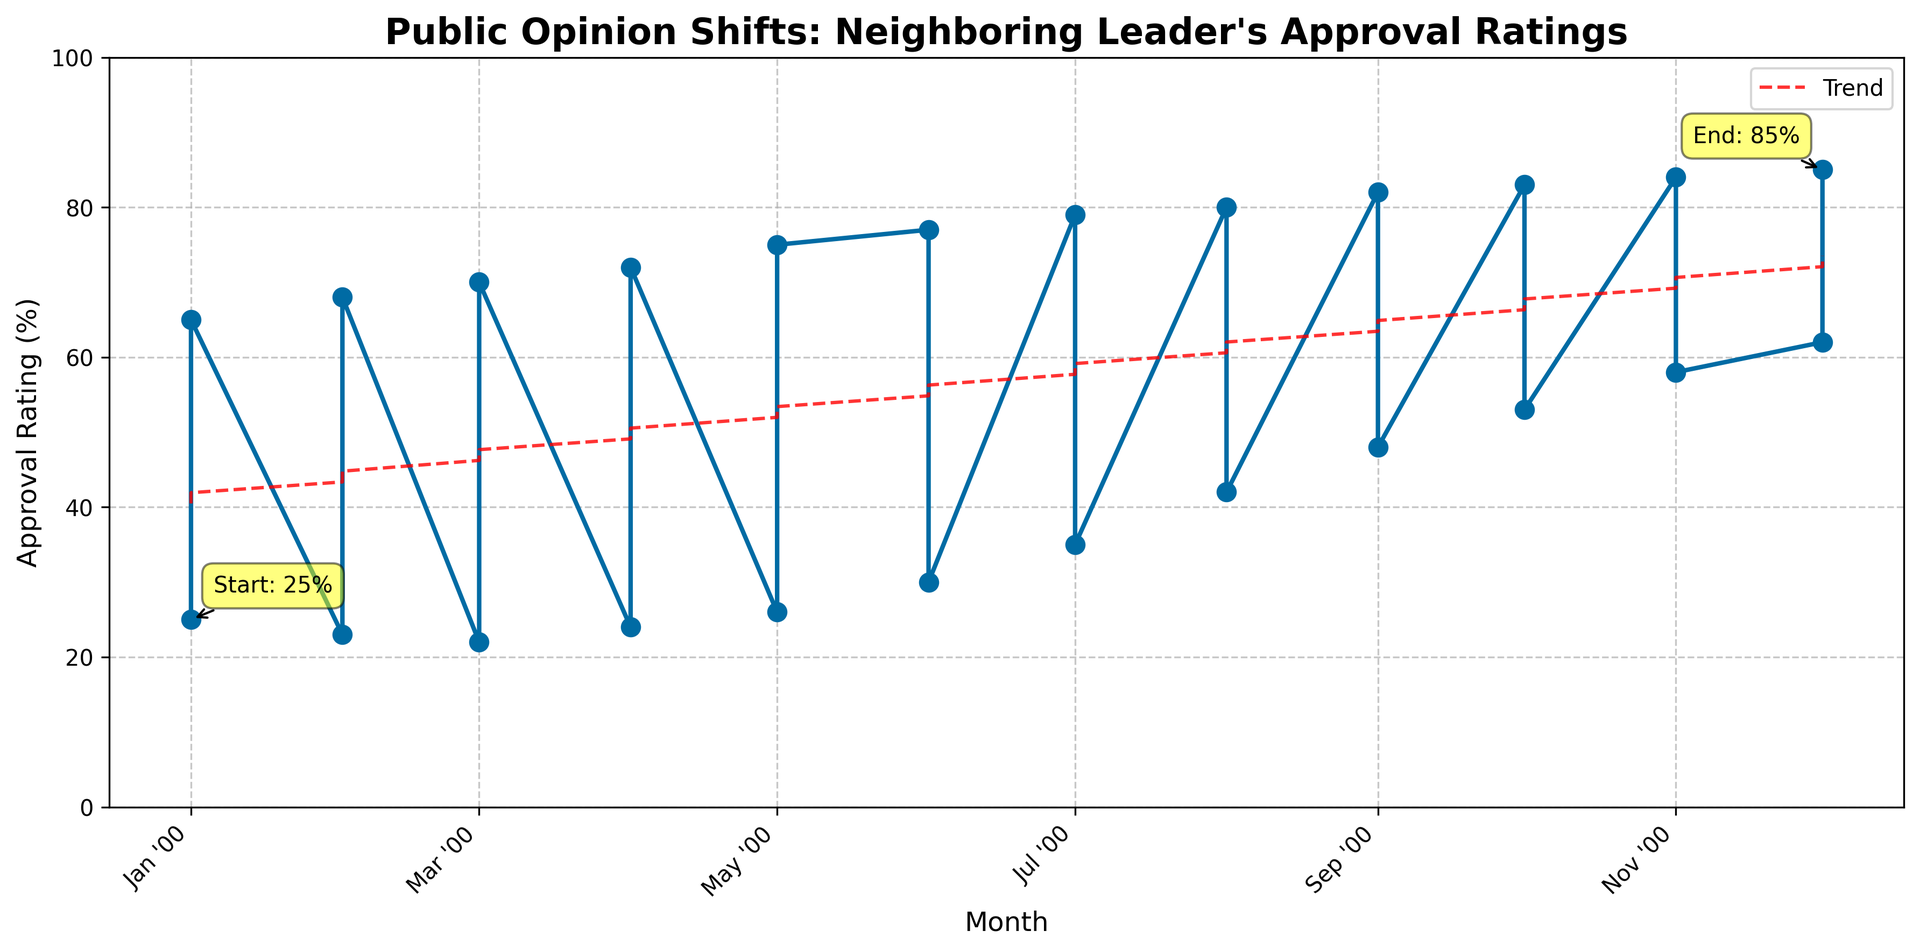What is the starting approval rating in January of the first year? The figure annotates the starting approval rating at the beginning of the plot. The annotation points to January of the first year with an approval rating of 25%.
Answer: 25% What is the approval rating in December of the second year? The figure annotates the ending approval rating at the end of the plot. The annotation points to December of the second year with an approval rating of 85%.
Answer: 85% By how much did the approval rating increase from January of the first year to December of the second year? Subtract the starting approval rating in January of the first year (25%) from the ending approval rating in December of the second year (85%). The increase is 85% - 25%.
Answer: 60% Between which two consecutive months did the largest increase in approval rating occur? By visually inspecting the steepness of the line between consecutive months, the greatest increase is between August and September of the first year, where the approval rating jumps from 42% to 48%.
Answer: August and September of the first year Is there any month where the approval rating decreased from the previous month? By following the line graph, it is noticeable that between January and March of the first year, the approval rating dips from 25% to 22%. This is the only period where a decrease is observed.
Answer: Yes, between January and March of the first year What is the overall trend in approval ratings over the two years? The trend line added to the plot shows a consistent upward trajectory throughout the two years, indicating a positive overall trend.
Answer: Positive Calculate the average approval rating for the second year. Sum the approval ratings from January to December of the second year (65, 68, 70, 72, 75, 77, 79, 80, 82, 83, 84, 85) and divide by 12. The sum is 920, and the average is 920/12.
Answer: 76.67% Compare the rate of increase in approval ratings between the first and the second half of the first year. Which half shows a higher rate of increase? The increase in the first half (January to June) is from 25% to 30%, which is an increase of 5%. In the second half (June to December), it increases from 30% to 62%, an increase of 32%. The second half shows a higher rate of increase.
Answer: The second half of the first year By how many percentage points did the approval rating increase in each month from January to April of the second year? Calculate the monthly increases: January to February (68% - 65%), February to March (70% - 68%), March to April (72% - 70%). The increases are 3%, 3%, and 2% respectively.
Answer: 3%, 3%, 2% 